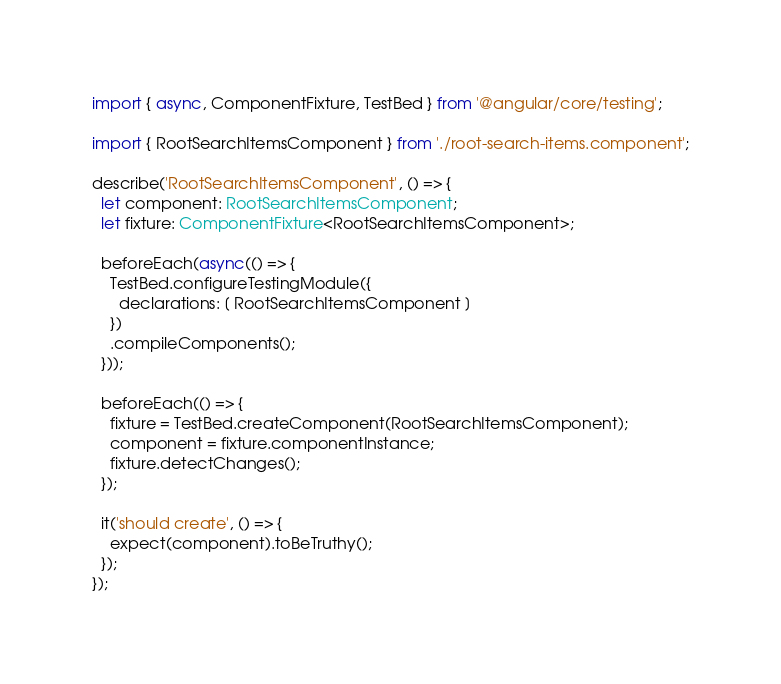<code> <loc_0><loc_0><loc_500><loc_500><_TypeScript_>import { async, ComponentFixture, TestBed } from '@angular/core/testing';

import { RootSearchItemsComponent } from './root-search-items.component';

describe('RootSearchItemsComponent', () => {
  let component: RootSearchItemsComponent;
  let fixture: ComponentFixture<RootSearchItemsComponent>;

  beforeEach(async(() => {
    TestBed.configureTestingModule({
      declarations: [ RootSearchItemsComponent ]
    })
    .compileComponents();
  }));

  beforeEach(() => {
    fixture = TestBed.createComponent(RootSearchItemsComponent);
    component = fixture.componentInstance;
    fixture.detectChanges();
  });

  it('should create', () => {
    expect(component).toBeTruthy();
  });
});
</code> 